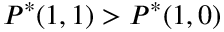<formula> <loc_0><loc_0><loc_500><loc_500>P ^ { * } ( 1 , 1 ) > P ^ { * } ( 1 , 0 )</formula> 